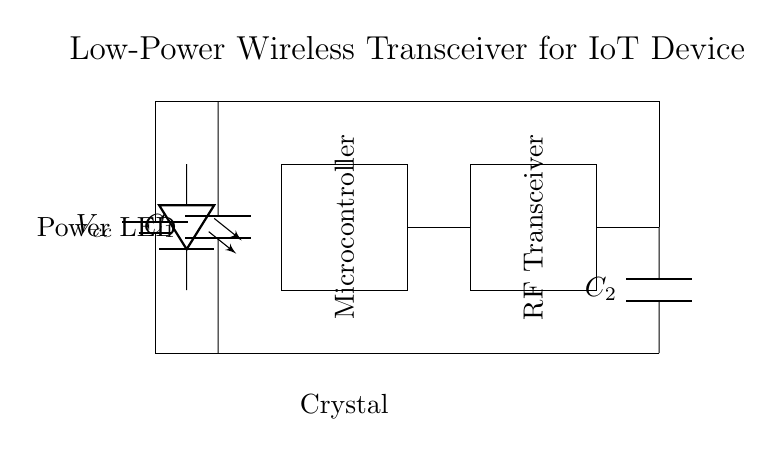What components are present in this circuit? The circuit includes a battery, microcontroller, RF transceiver, antenna, capacitors, crystal oscillator, and a power LED. Each component is visually represented in the diagram, making them identifiable.
Answer: battery, microcontroller, RF transceiver, antenna, capacitors, crystal oscillator, power LED What is the purpose of the crystal oscillator in the circuit? The crystal oscillator is used to provide a stable frequency reference for the microcontroller and RF transceiver, essential for synchronous communication. Its role is clearly indicated in the diagram as a frequency-generating element.
Answer: frequency reference What is the connection between the microcontroller and the RF transceiver? The microcontroller is directly connected to the RF transceiver through a wire, which shows that it sends and receives data to facilitate IoT device communication. The diagram explicitly illustrates this connection.
Answer: direct connection How is the power supplied to the components? The power is supplied from the battery, which is connected to all components in the circuit via a common power line, ensuring they receive the necessary voltage to operate. This is visually depicted in the diagram through the connections.
Answer: battery What is the function of the power LED in this circuit? The power LED serves as an indicator that the circuit is powered on. It shows visual feedback that the device is operational whenever power is supplied from the battery. Its positioning in the diagram indicates its connection to the power source.
Answer: status indicator Why is a capacitor used in this low-power circuit? Capacitors are employed to stabilize voltage and filter out noise, which is crucial for low-power circuit performance, ensuring reliable communication without interference. In the diagram, the capacitor symbols are marked clearly, indicating their role in the circuit.
Answer: voltage stabilization How does the antenna contribute to the circuit's functionality? The antenna is essential for wireless communication as it transmits and receives radio frequency signals between the IoT device and other devices or networks. Its connection to the RF transceiver in the diagram signifies its critical role.
Answer: wireless communication 